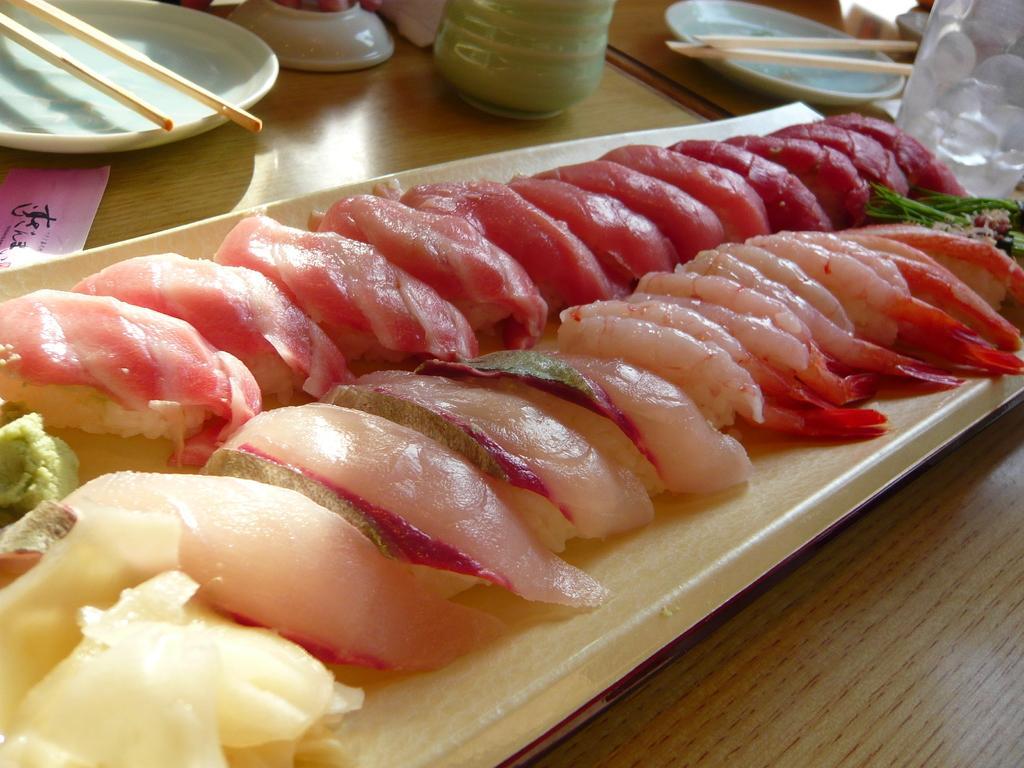In one or two sentences, can you explain what this image depicts? In this Image I see food and plates on which there are chopsticks. 